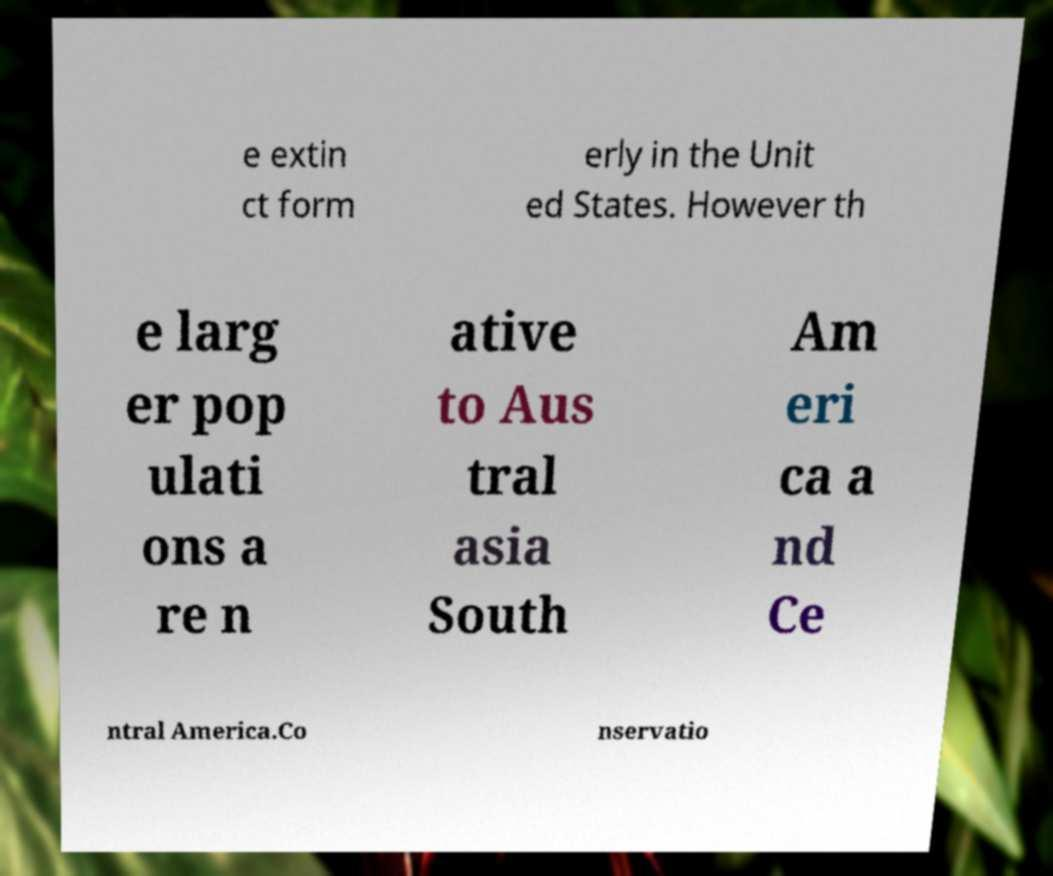Please read and relay the text visible in this image. What does it say? e extin ct form erly in the Unit ed States. However th e larg er pop ulati ons a re n ative to Aus tral asia South Am eri ca a nd Ce ntral America.Co nservatio 